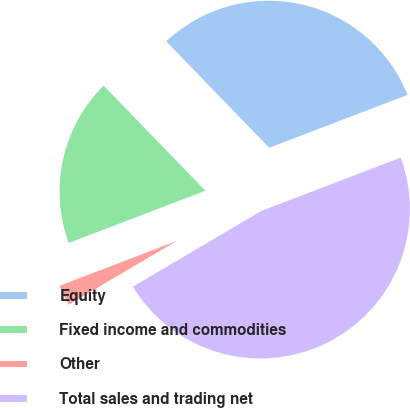<chart> <loc_0><loc_0><loc_500><loc_500><pie_chart><fcel>Equity<fcel>Fixed income and commodities<fcel>Other<fcel>Total sales and trading net<nl><fcel>31.43%<fcel>18.57%<fcel>2.67%<fcel>47.33%<nl></chart> 